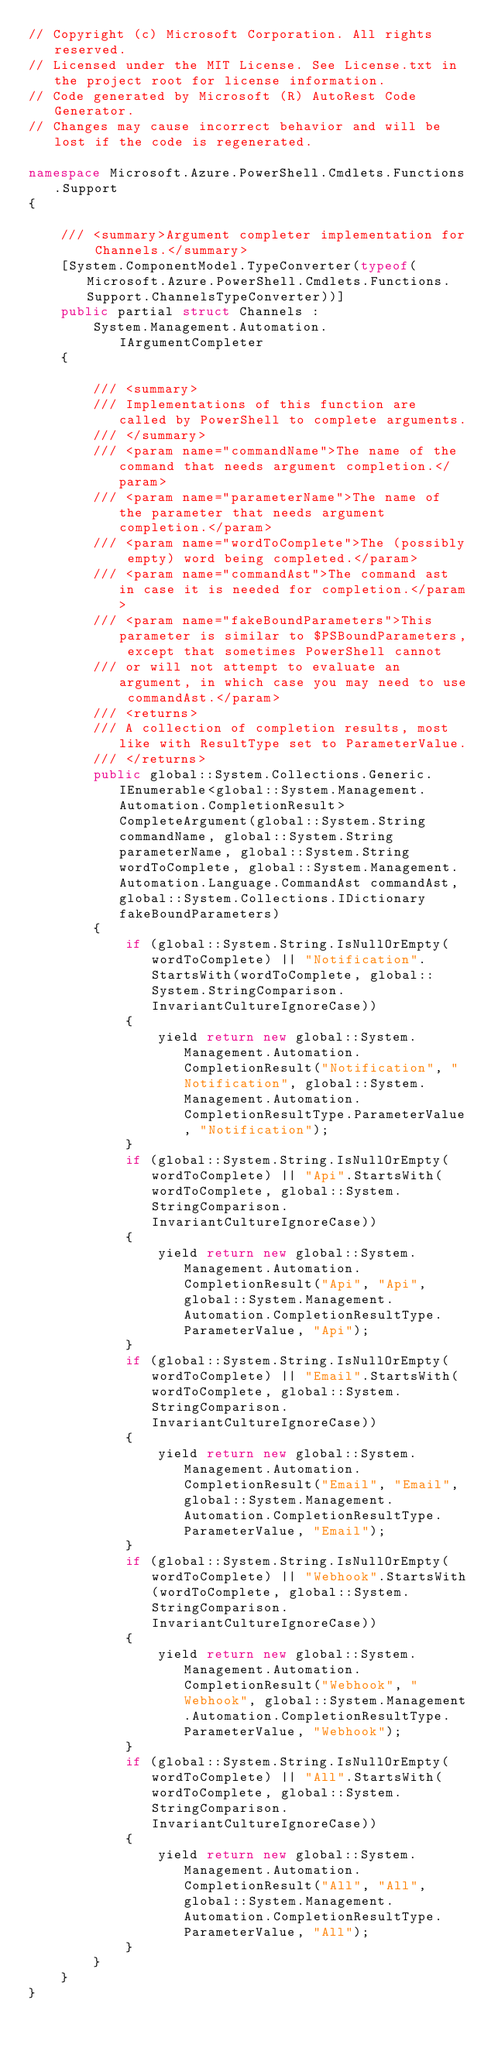Convert code to text. <code><loc_0><loc_0><loc_500><loc_500><_C#_>// Copyright (c) Microsoft Corporation. All rights reserved.
// Licensed under the MIT License. See License.txt in the project root for license information.
// Code generated by Microsoft (R) AutoRest Code Generator.
// Changes may cause incorrect behavior and will be lost if the code is regenerated.

namespace Microsoft.Azure.PowerShell.Cmdlets.Functions.Support
{

    /// <summary>Argument completer implementation for Channels.</summary>
    [System.ComponentModel.TypeConverter(typeof(Microsoft.Azure.PowerShell.Cmdlets.Functions.Support.ChannelsTypeConverter))]
    public partial struct Channels :
        System.Management.Automation.IArgumentCompleter
    {

        /// <summary>
        /// Implementations of this function are called by PowerShell to complete arguments.
        /// </summary>
        /// <param name="commandName">The name of the command that needs argument completion.</param>
        /// <param name="parameterName">The name of the parameter that needs argument completion.</param>
        /// <param name="wordToComplete">The (possibly empty) word being completed.</param>
        /// <param name="commandAst">The command ast in case it is needed for completion.</param>
        /// <param name="fakeBoundParameters">This parameter is similar to $PSBoundParameters, except that sometimes PowerShell cannot
        /// or will not attempt to evaluate an argument, in which case you may need to use commandAst.</param>
        /// <returns>
        /// A collection of completion results, most like with ResultType set to ParameterValue.
        /// </returns>
        public global::System.Collections.Generic.IEnumerable<global::System.Management.Automation.CompletionResult> CompleteArgument(global::System.String commandName, global::System.String parameterName, global::System.String wordToComplete, global::System.Management.Automation.Language.CommandAst commandAst, global::System.Collections.IDictionary fakeBoundParameters)
        {
            if (global::System.String.IsNullOrEmpty(wordToComplete) || "Notification".StartsWith(wordToComplete, global::System.StringComparison.InvariantCultureIgnoreCase))
            {
                yield return new global::System.Management.Automation.CompletionResult("Notification", "Notification", global::System.Management.Automation.CompletionResultType.ParameterValue, "Notification");
            }
            if (global::System.String.IsNullOrEmpty(wordToComplete) || "Api".StartsWith(wordToComplete, global::System.StringComparison.InvariantCultureIgnoreCase))
            {
                yield return new global::System.Management.Automation.CompletionResult("Api", "Api", global::System.Management.Automation.CompletionResultType.ParameterValue, "Api");
            }
            if (global::System.String.IsNullOrEmpty(wordToComplete) || "Email".StartsWith(wordToComplete, global::System.StringComparison.InvariantCultureIgnoreCase))
            {
                yield return new global::System.Management.Automation.CompletionResult("Email", "Email", global::System.Management.Automation.CompletionResultType.ParameterValue, "Email");
            }
            if (global::System.String.IsNullOrEmpty(wordToComplete) || "Webhook".StartsWith(wordToComplete, global::System.StringComparison.InvariantCultureIgnoreCase))
            {
                yield return new global::System.Management.Automation.CompletionResult("Webhook", "Webhook", global::System.Management.Automation.CompletionResultType.ParameterValue, "Webhook");
            }
            if (global::System.String.IsNullOrEmpty(wordToComplete) || "All".StartsWith(wordToComplete, global::System.StringComparison.InvariantCultureIgnoreCase))
            {
                yield return new global::System.Management.Automation.CompletionResult("All", "All", global::System.Management.Automation.CompletionResultType.ParameterValue, "All");
            }
        }
    }
}</code> 